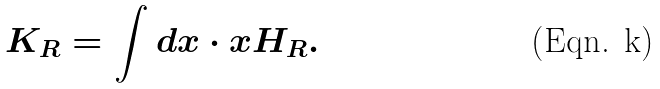<formula> <loc_0><loc_0><loc_500><loc_500>K _ { R } = \int d x \cdot x H _ { R } .</formula> 